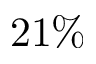<formula> <loc_0><loc_0><loc_500><loc_500>2 1 \%</formula> 